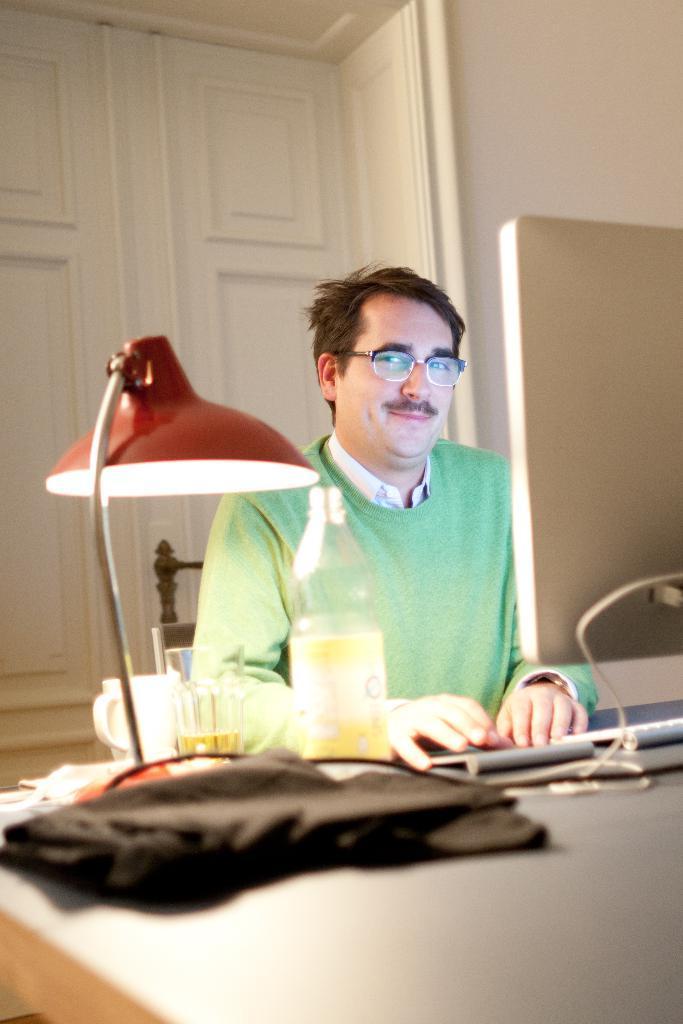Can you describe this image briefly? This is a picture of a man in green t shirt sitting on a chair in front of the man there is a table on the table there are cloth, lamp, glass, cup, keyboard and monitor. Background of the man is a wall. 